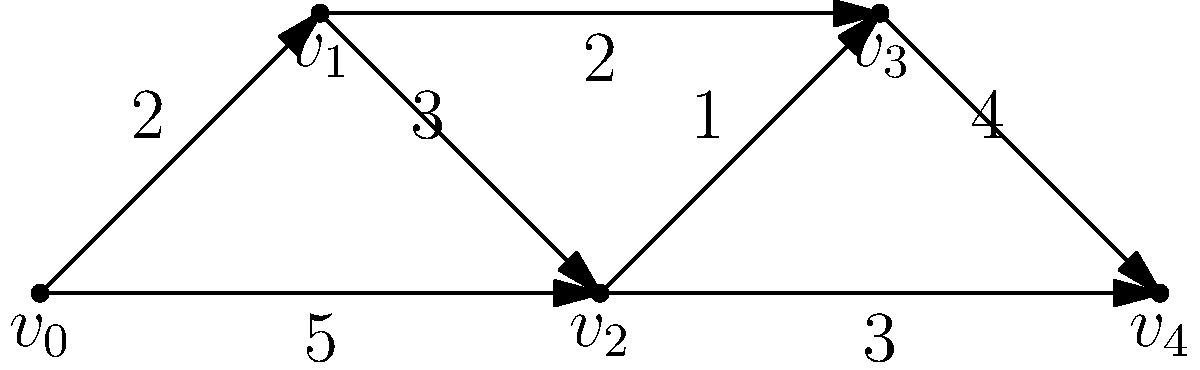As an aspiring film editor inspired by Orlee Buium's innovative techniques, you're working on optimizing the arrangement of video clips on a timeline. The weighted graph above represents potential transitions between clips, where vertices represent clips and edge weights indicate transition smoothness (higher is smoother). What is the smoothest path from $v_0$ to $v_4$, and what is its total smoothness score? To find the smoothest path from $v_0$ to $v_4$, we need to consider all possible paths and their total smoothness scores. Let's break it down step-by-step:

1. Identify all possible paths from $v_0$ to $v_4$:
   - Path 1: $v_0 \rightarrow v_1 \rightarrow v_2 \rightarrow v_3 \rightarrow v_4$
   - Path 2: $v_0 \rightarrow v_1 \rightarrow v_3 \rightarrow v_4$
   - Path 3: $v_0 \rightarrow v_2 \rightarrow v_3 \rightarrow v_4$
   - Path 4: $v_0 \rightarrow v_2 \rightarrow v_4$

2. Calculate the total smoothness score for each path:
   - Path 1: $2 + 3 + 1 + 4 = 10$
   - Path 2: $2 + 2 + 4 = 8$
   - Path 3: $5 + 1 + 4 = 10$
   - Path 4: $5 + 3 = 8$

3. Identify the path(s) with the highest total smoothness score:
   - Paths 1 and 3 both have the highest score of 10.

4. Choose the optimal path:
   - Both Path 1 ($v_0 \rightarrow v_1 \rightarrow v_2 \rightarrow v_3 \rightarrow v_4$) and Path 3 ($v_0 \rightarrow v_2 \rightarrow v_3 \rightarrow v_4$) are equally smooth.
   - We can choose either, but let's select Path 1 as it includes more transitions, potentially offering more creative opportunities.

Therefore, the smoothest path from $v_0$ to $v_4$ is $v_0 \rightarrow v_1 \rightarrow v_2 \rightarrow v_3 \rightarrow v_4$, with a total smoothness score of 10.
Answer: $v_0 \rightarrow v_1 \rightarrow v_2 \rightarrow v_3 \rightarrow v_4$; 10 